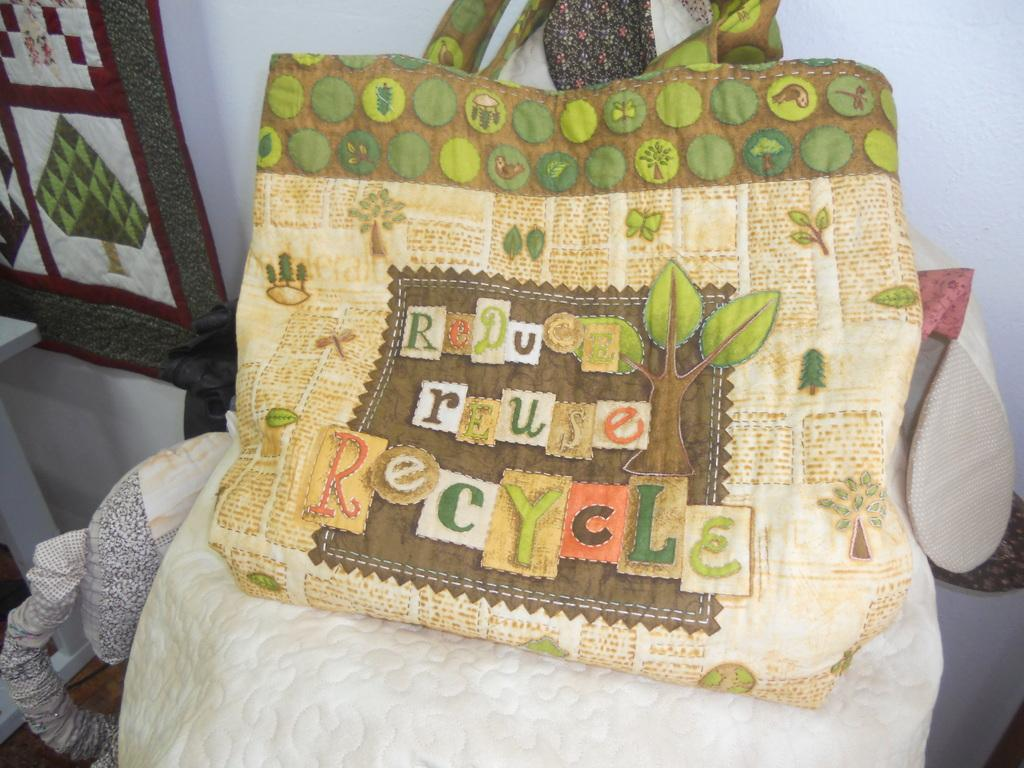What object is visible in the image? There is a bag in the image. Where is the bag placed? The bag is placed on a white cloth. What is depicted on the bag? The bag has a drawing of a tree on earth. What elements are included in the drawing? The drawing includes leaves and butterflies. What type of scent can be detected from the bag in the image? There is no information about the scent of the bag in the image, so it cannot be determined. 